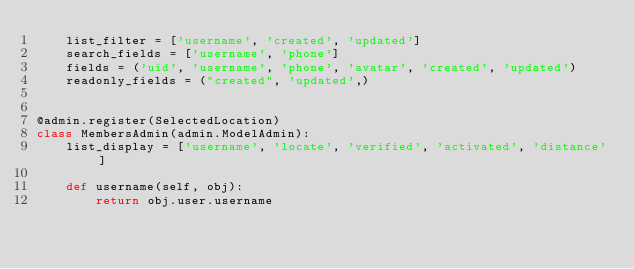<code> <loc_0><loc_0><loc_500><loc_500><_Python_>    list_filter = ['username', 'created', 'updated']
    search_fields = ['username', 'phone']
    fields = ('uid', 'username', 'phone', 'avatar', 'created', 'updated')
    readonly_fields = ("created", 'updated',)


@admin.register(SelectedLocation)
class MembersAdmin(admin.ModelAdmin):
    list_display = ['username', 'locate', 'verified', 'activated', 'distance']

    def username(self, obj):
        return obj.user.username
</code> 